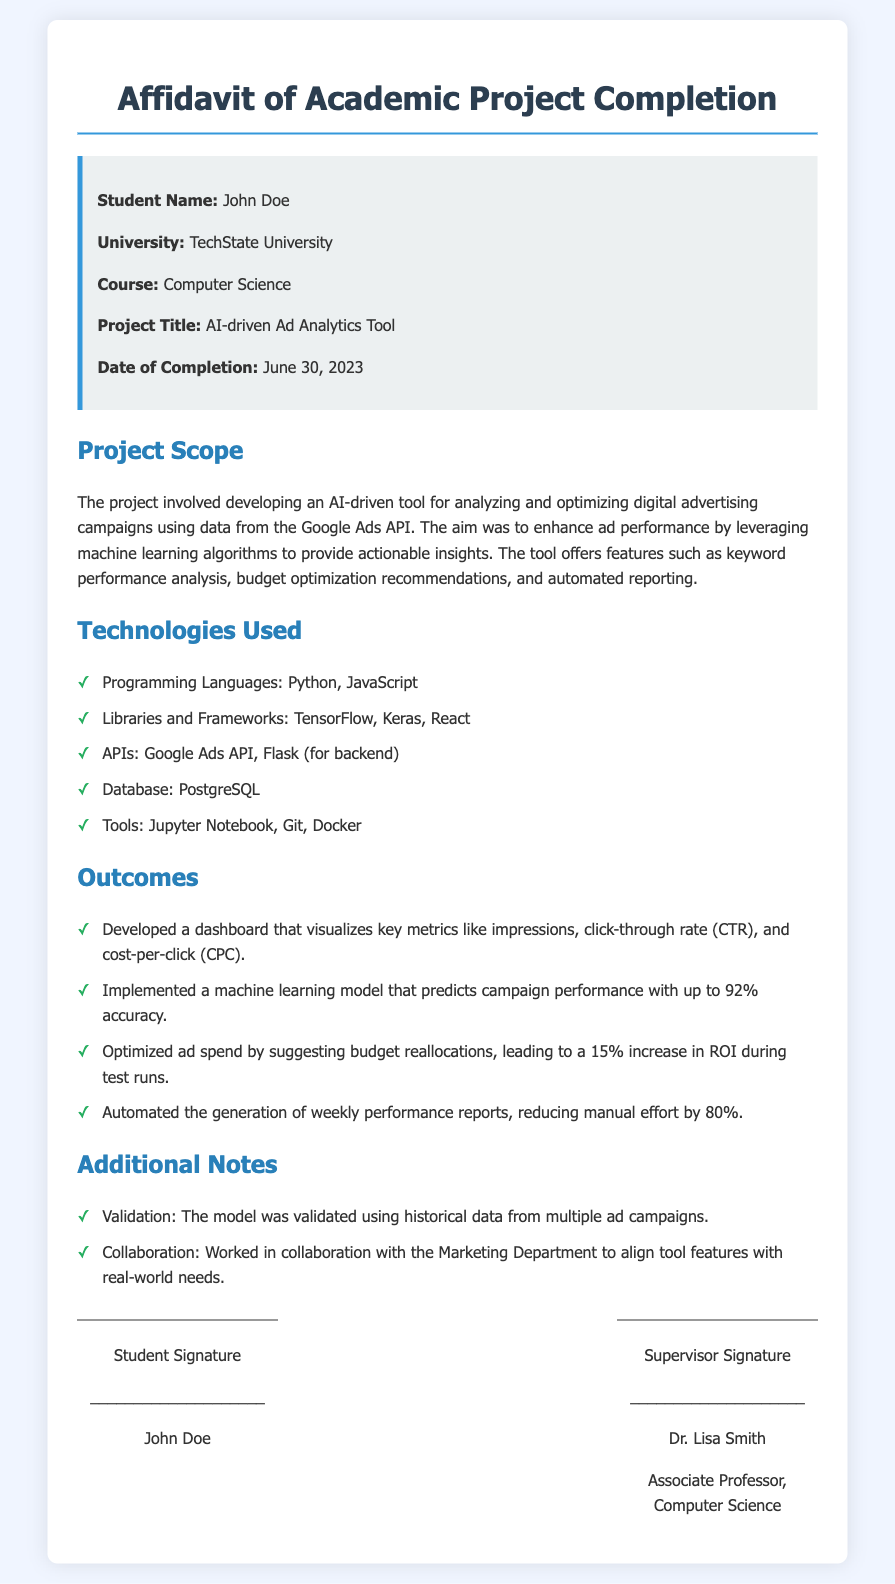What is the student's name? The student's name is mentioned in the project details section of the document.
Answer: John Doe What is the project title? The project title is stated clearly in the document under project details.
Answer: AI-driven Ad Analytics Tool When was the project completed? The completion date of the project is specified in the project details section.
Answer: June 30, 2023 What library was used for machine learning? The document lists technologies used, specifically mentioning certain libraries.
Answer: TensorFlow What percentage of accuracy does the machine learning model predict? The accuracy of the machine learning model is stated in the outcomes section.
Answer: 92% How much did ROI increase during test runs? The document indicates the increase in ROI as a result of budget optimization efforts.
Answer: 15% Which database technology was used? The technologies used section mentions the database technology utilized in the project.
Answer: PostgreSQL Who is the supervisor? The supervisor's name is noted in the signature section of the document.
Answer: Dr. Lisa Smith What feature does the dashboard visualize? The features of the dashboard are mentioned in the outcomes section.
Answer: Key metrics like impressions, click-through rate, and cost-per-click 